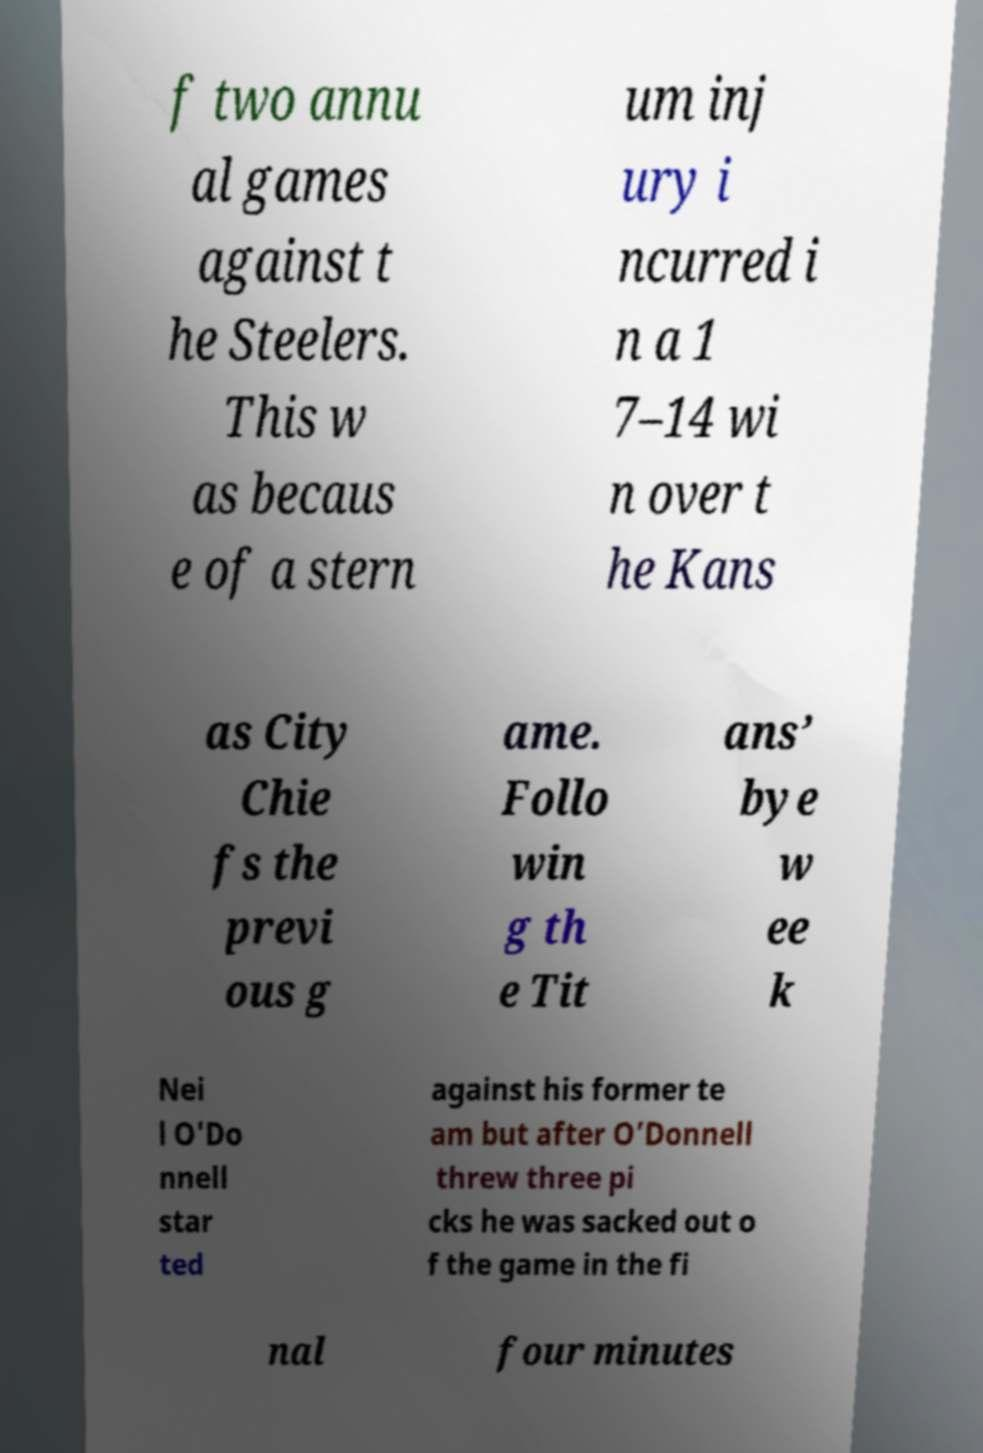Can you accurately transcribe the text from the provided image for me? f two annu al games against t he Steelers. This w as becaus e of a stern um inj ury i ncurred i n a 1 7–14 wi n over t he Kans as City Chie fs the previ ous g ame. Follo win g th e Tit ans’ bye w ee k Nei l O'Do nnell star ted against his former te am but after O’Donnell threw three pi cks he was sacked out o f the game in the fi nal four minutes 